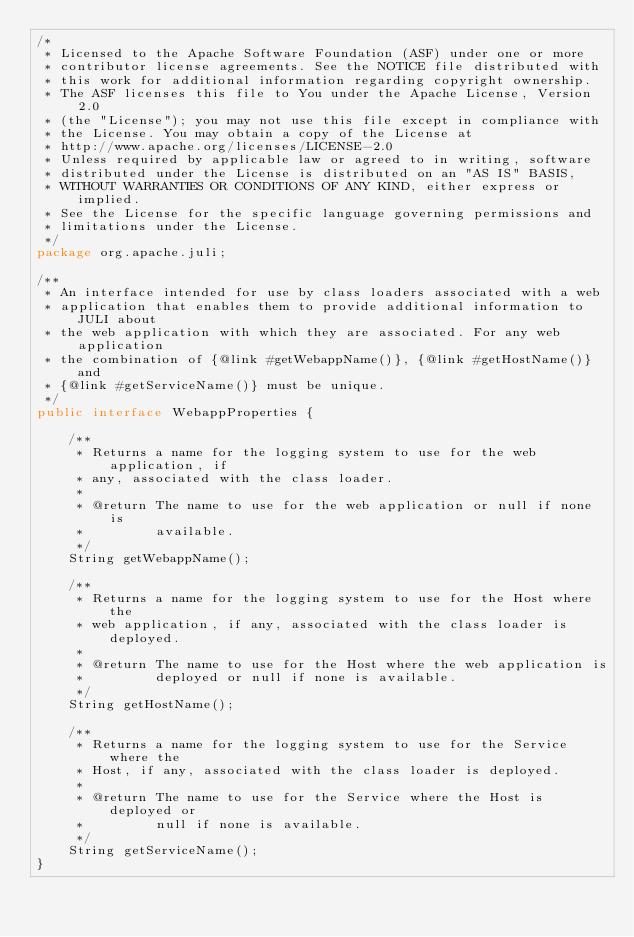Convert code to text. <code><loc_0><loc_0><loc_500><loc_500><_Java_>/*
 * Licensed to the Apache Software Foundation (ASF) under one or more
 * contributor license agreements. See the NOTICE file distributed with
 * this work for additional information regarding copyright ownership.
 * The ASF licenses this file to You under the Apache License, Version 2.0
 * (the "License"); you may not use this file except in compliance with
 * the License. You may obtain a copy of the License at
 * http://www.apache.org/licenses/LICENSE-2.0
 * Unless required by applicable law or agreed to in writing, software
 * distributed under the License is distributed on an "AS IS" BASIS,
 * WITHOUT WARRANTIES OR CONDITIONS OF ANY KIND, either express or implied.
 * See the License for the specific language governing permissions and
 * limitations under the License.
 */
package org.apache.juli;

/**
 * An interface intended for use by class loaders associated with a web
 * application that enables them to provide additional information to JULI about
 * the web application with which they are associated. For any web application
 * the combination of {@link #getWebappName()}, {@link #getHostName()} and
 * {@link #getServiceName()} must be unique.
 */
public interface WebappProperties {

    /**
     * Returns a name for the logging system to use for the web application, if
     * any, associated with the class loader.
     *
     * @return The name to use for the web application or null if none is
     *         available.
     */
    String getWebappName();

    /**
     * Returns a name for the logging system to use for the Host where the
     * web application, if any, associated with the class loader is deployed.
     *
     * @return The name to use for the Host where the web application is
     *         deployed or null if none is available.
     */
    String getHostName();

    /**
     * Returns a name for the logging system to use for the Service where the
     * Host, if any, associated with the class loader is deployed.
     *
     * @return The name to use for the Service where the Host is deployed or
     *         null if none is available.
     */
    String getServiceName();
}
</code> 